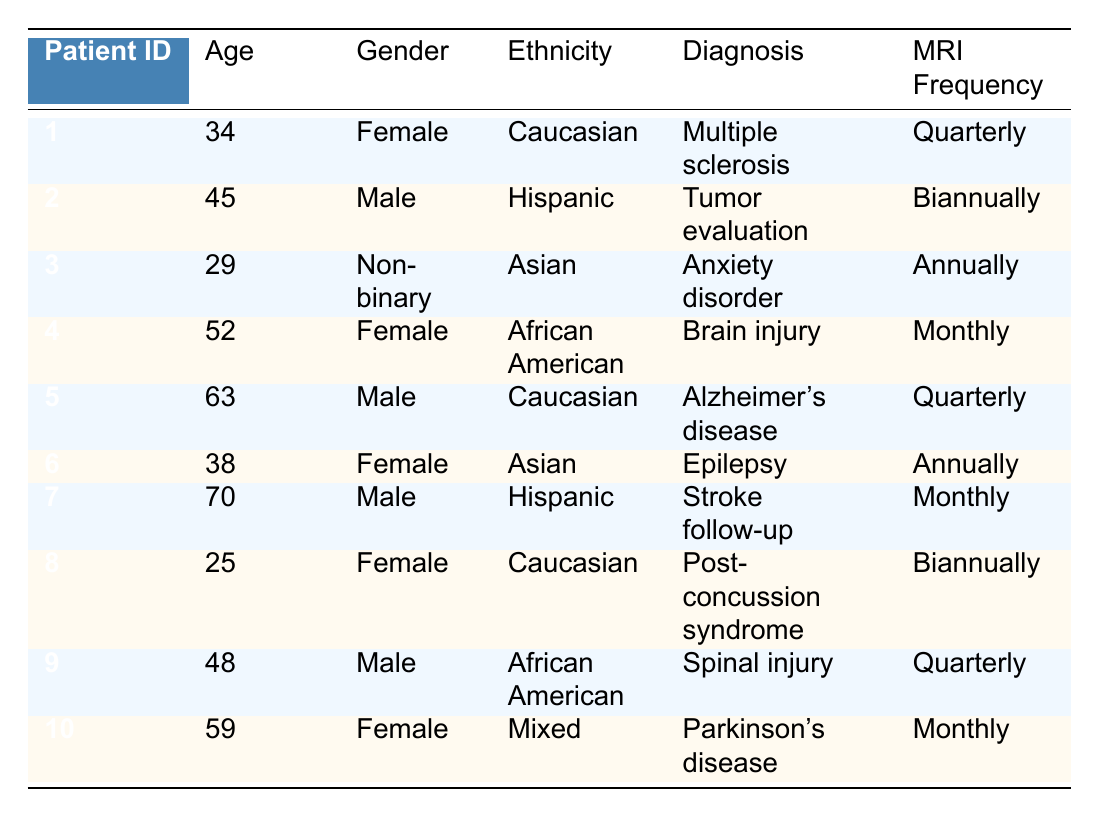What is the MRIFrequency for PatientID 6? According to the table, PatientID 6 corresponds to the entry where the MRI Frequency is listed as "Annually".
Answer: Annually How many patients have a diagnosis of "Quarterly" in their MRIFrequency? There are three entries in the table with "Quarterly" MRI Frequency for PatientID 1, PatientID 5, and PatientID 9. Therefore, the total count is 3.
Answer: 3 Is there a male patient diagnosed with "Brain injury"? The table indicates that PatientID 4, who is identified as female, has the diagnosis of "Brain injury". No male patients have this diagnosis.
Answer: No What is the average age of patients with a monthly MRI frequency? The monthly MRI frequency is associated with PatientID 4 (age 52), PatientID 7 (age 70), and PatientID 10 (age 59). The total age is 52 + 70 + 59 = 181. The average age is 181 / 3 = 60.33.
Answer: 60.33 Which ethnic group has the most patients that require MRI scans biannually? The only patient with "Biannually" MRIFrequency is PatientID 2, who is of Hispanic ethnicity. Therefore, the Hispanic group has the most patients requiring biannual MRIs, with just one patient in this category.
Answer: Hispanic How often do female patients require MRI scans compared to male patients? Female patients (4 entries with frequencies "Quarterly", "Monthly", "Annually", "Biannually") include 4 frequencies: 1 Quarterly, 1 Monthly, 1 Annually, and 1 Biannually. Male patients (3 entries with frequencies "Biannually", "Quarterly", "Monthly") have the same total of 4 frequencies: 1 Biannually, 2 Quarterly, and 1 Monthly. The frequency of scans for each gender is therefore equal.
Answer: Equal Which patient requires an MRI more frequently, PatientID 4 or PatientID 7? PatientID 4 has a monthly frequency while PatientID 7 also has a monthly frequency for MRI scanning. Neither requires more frequent scans than the other since both are the same.
Answer: Neither Is the average age of patients with Alzheimer’s disease younger than 60 years? The only patient diagnosed with Alzheimer’s disease is PatientID 5, who is 63 years old. Since this is clearly over 60, the average age is not younger than 60 years.
Answer: No 